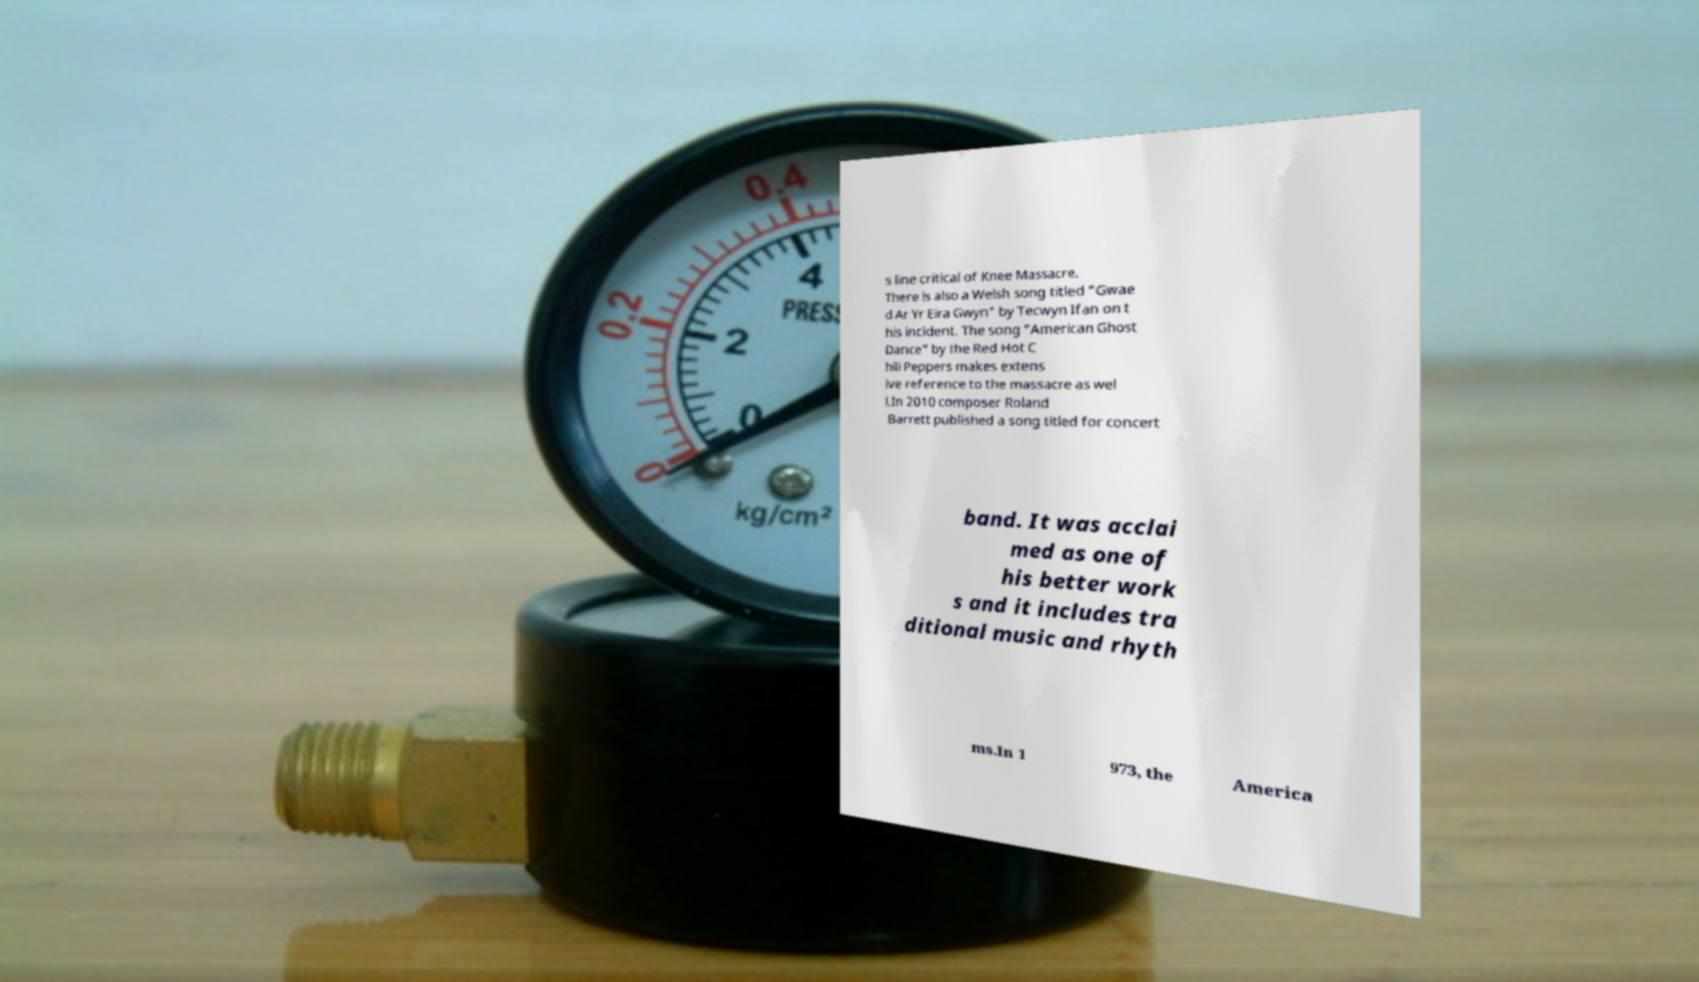For documentation purposes, I need the text within this image transcribed. Could you provide that? s line critical of Knee Massacre. There is also a Welsh song titled "Gwae d Ar Yr Eira Gwyn" by Tecwyn Ifan on t his incident. The song "American Ghost Dance" by the Red Hot C hili Peppers makes extens ive reference to the massacre as wel l.In 2010 composer Roland Barrett published a song titled for concert band. It was acclai med as one of his better work s and it includes tra ditional music and rhyth ms.In 1 973, the America 